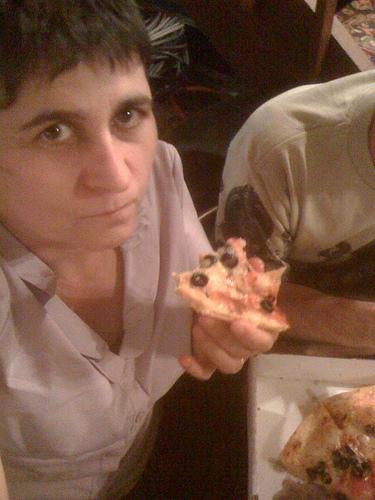Is this person taking a selfie?
Short answer required. Yes. What color is the person's shirt?
Be succinct. White. What is this person eating?
Answer briefly. Pizza. 